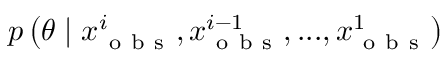<formula> <loc_0><loc_0><loc_500><loc_500>p \left ( \theta | x _ { o b s } ^ { i } , x _ { o b s } ^ { i - 1 } , \dots , x _ { o b s } ^ { 1 } \right )</formula> 